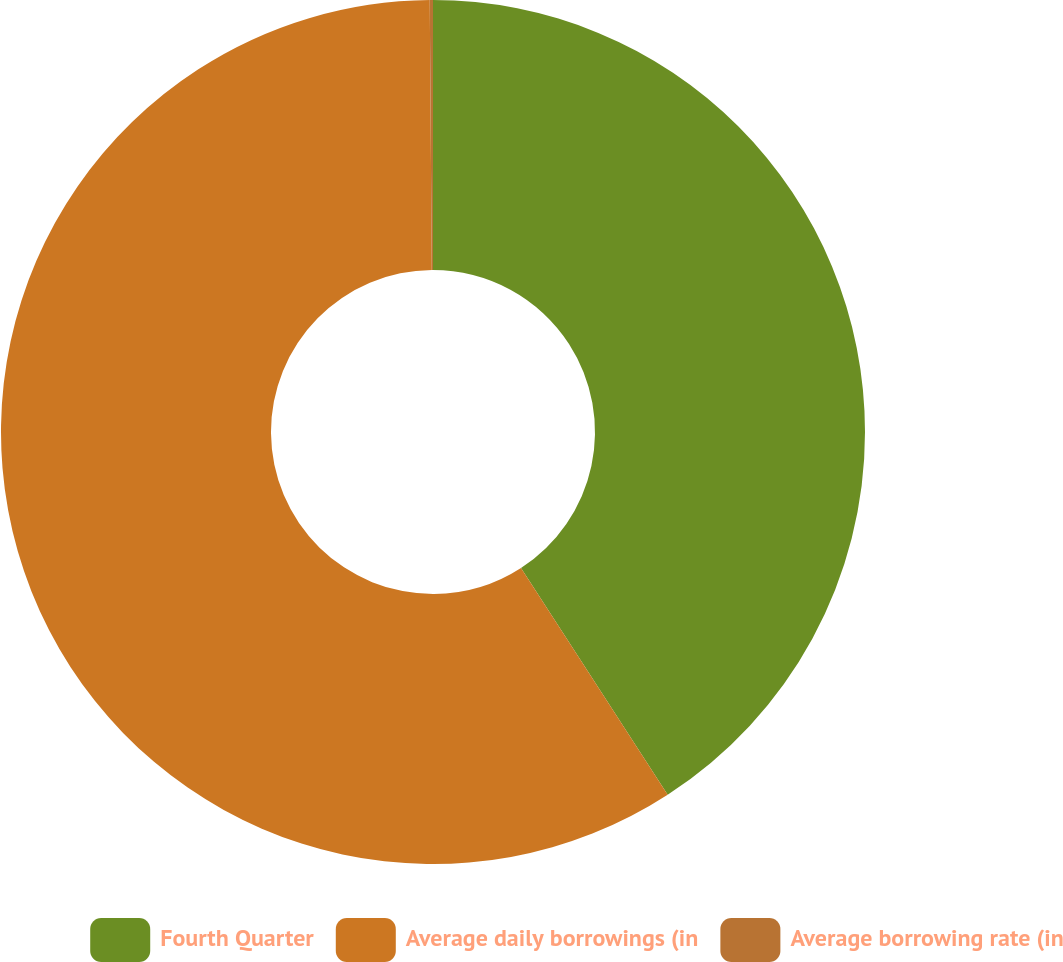Convert chart to OTSL. <chart><loc_0><loc_0><loc_500><loc_500><pie_chart><fcel>Fourth Quarter<fcel>Average daily borrowings (in<fcel>Average borrowing rate (in<nl><fcel>40.86%<fcel>59.02%<fcel>0.12%<nl></chart> 